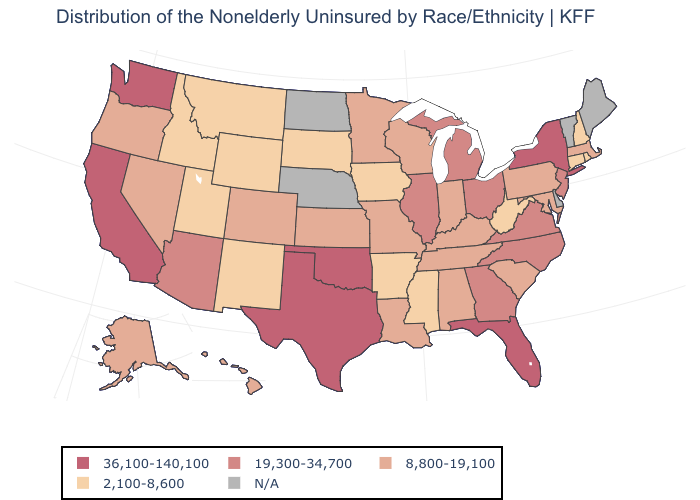Does the map have missing data?
Keep it brief. Yes. How many symbols are there in the legend?
Keep it brief. 5. Does the map have missing data?
Be succinct. Yes. Is the legend a continuous bar?
Write a very short answer. No. What is the lowest value in states that border Wyoming?
Concise answer only. 2,100-8,600. Which states hav the highest value in the Northeast?
Keep it brief. New York. What is the highest value in states that border Virginia?
Write a very short answer. 19,300-34,700. What is the value of South Dakota?
Write a very short answer. 2,100-8,600. Which states have the highest value in the USA?
Concise answer only. California, Florida, New York, Oklahoma, Texas, Washington. Which states have the lowest value in the Northeast?
Short answer required. Connecticut, New Hampshire, Rhode Island. What is the value of Maryland?
Short answer required. 8,800-19,100. Which states have the lowest value in the USA?
Give a very brief answer. Arkansas, Connecticut, Idaho, Iowa, Mississippi, Montana, New Hampshire, New Mexico, Rhode Island, South Dakota, Utah, West Virginia, Wyoming. What is the value of Georgia?
Concise answer only. 19,300-34,700. What is the lowest value in states that border Tennessee?
Write a very short answer. 2,100-8,600. 